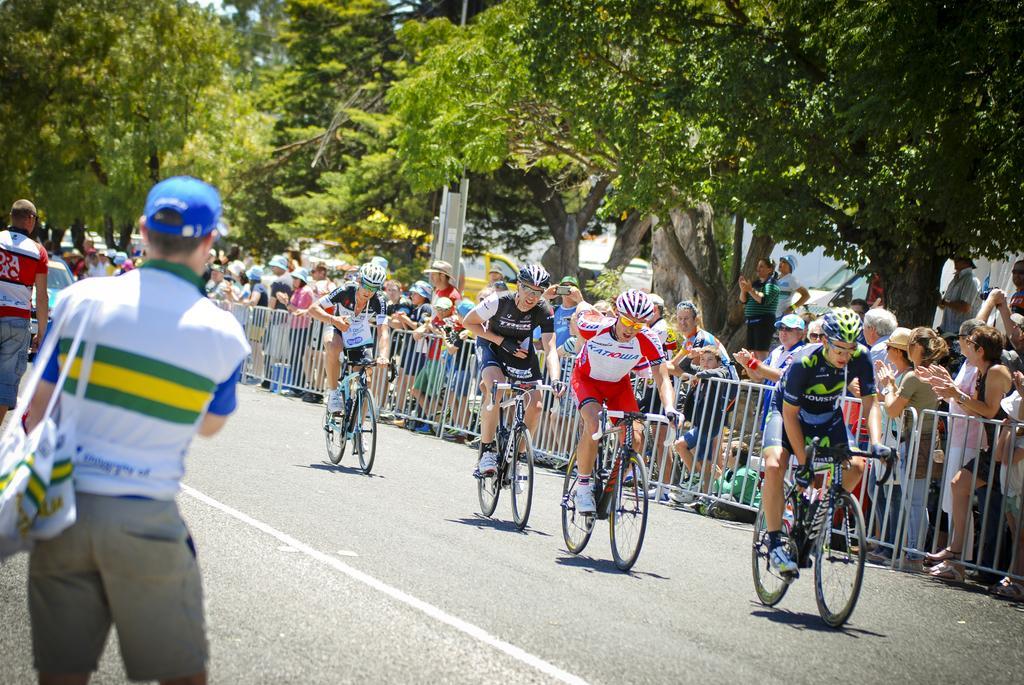Please provide a concise description of this image. In this image there are group of people riding bicycles on a road. Some of the people are staring at them behind the fence. To the left side there is a person with white t shirt and grey shorts is holding a bag. In the background there are some trees, houses and trucks. 